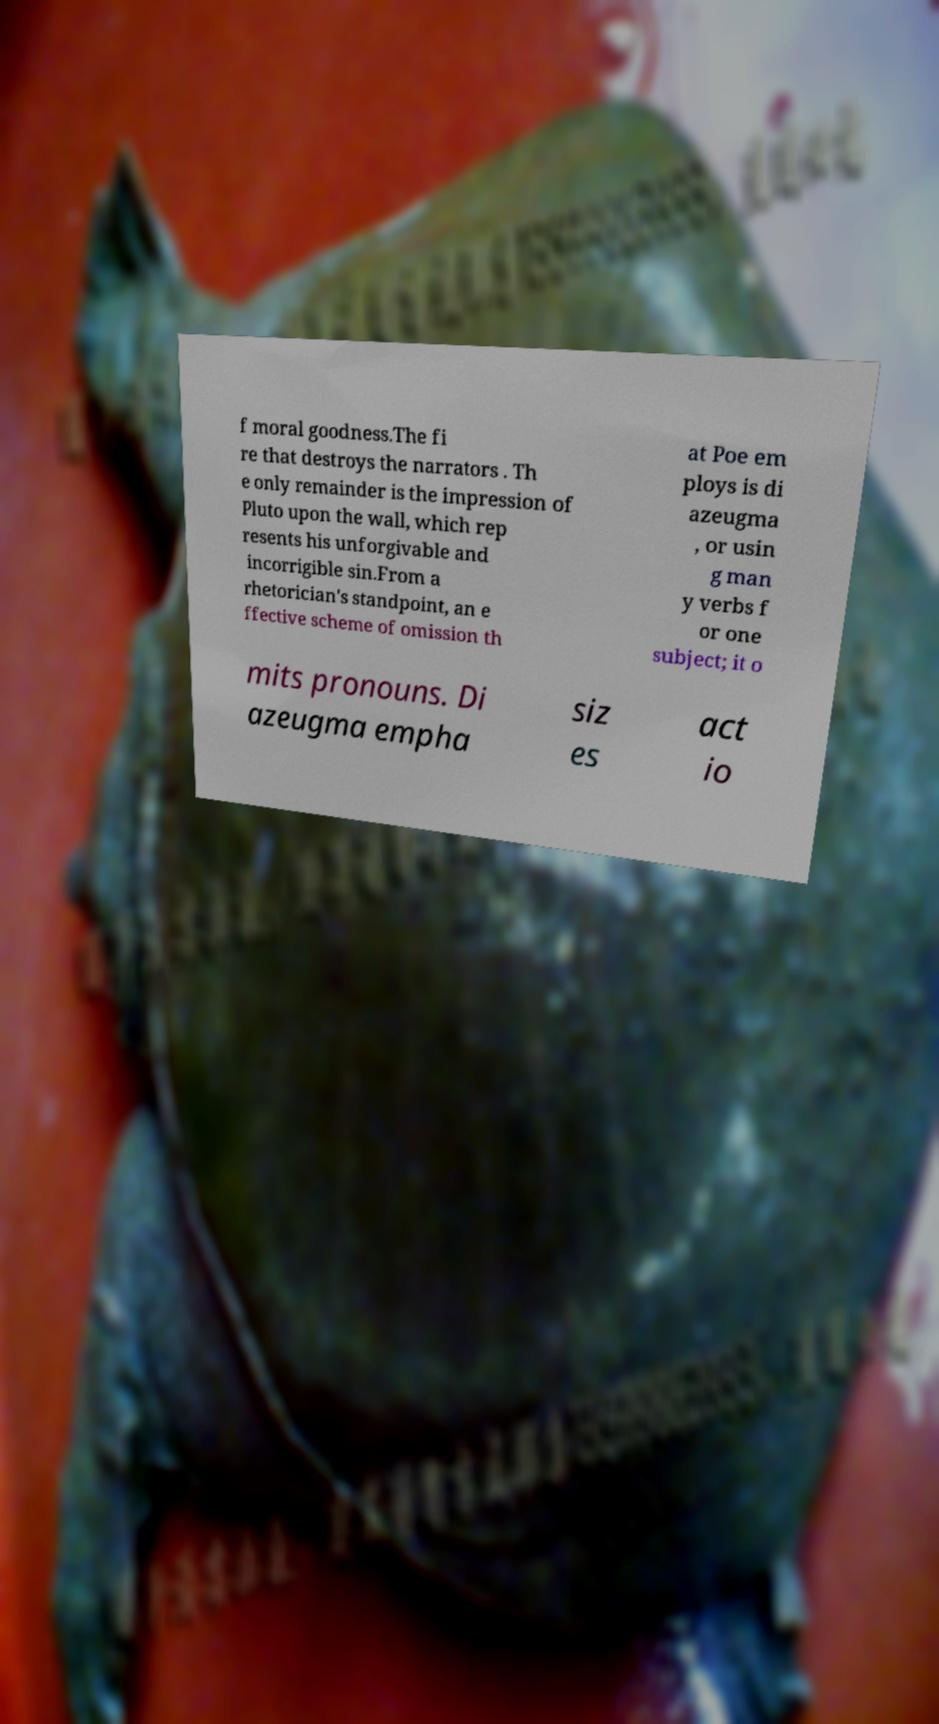I need the written content from this picture converted into text. Can you do that? f moral goodness.The fi re that destroys the narrators . Th e only remainder is the impression of Pluto upon the wall, which rep resents his unforgivable and incorrigible sin.From a rhetorician's standpoint, an e ffective scheme of omission th at Poe em ploys is di azeugma , or usin g man y verbs f or one subject; it o mits pronouns. Di azeugma empha siz es act io 